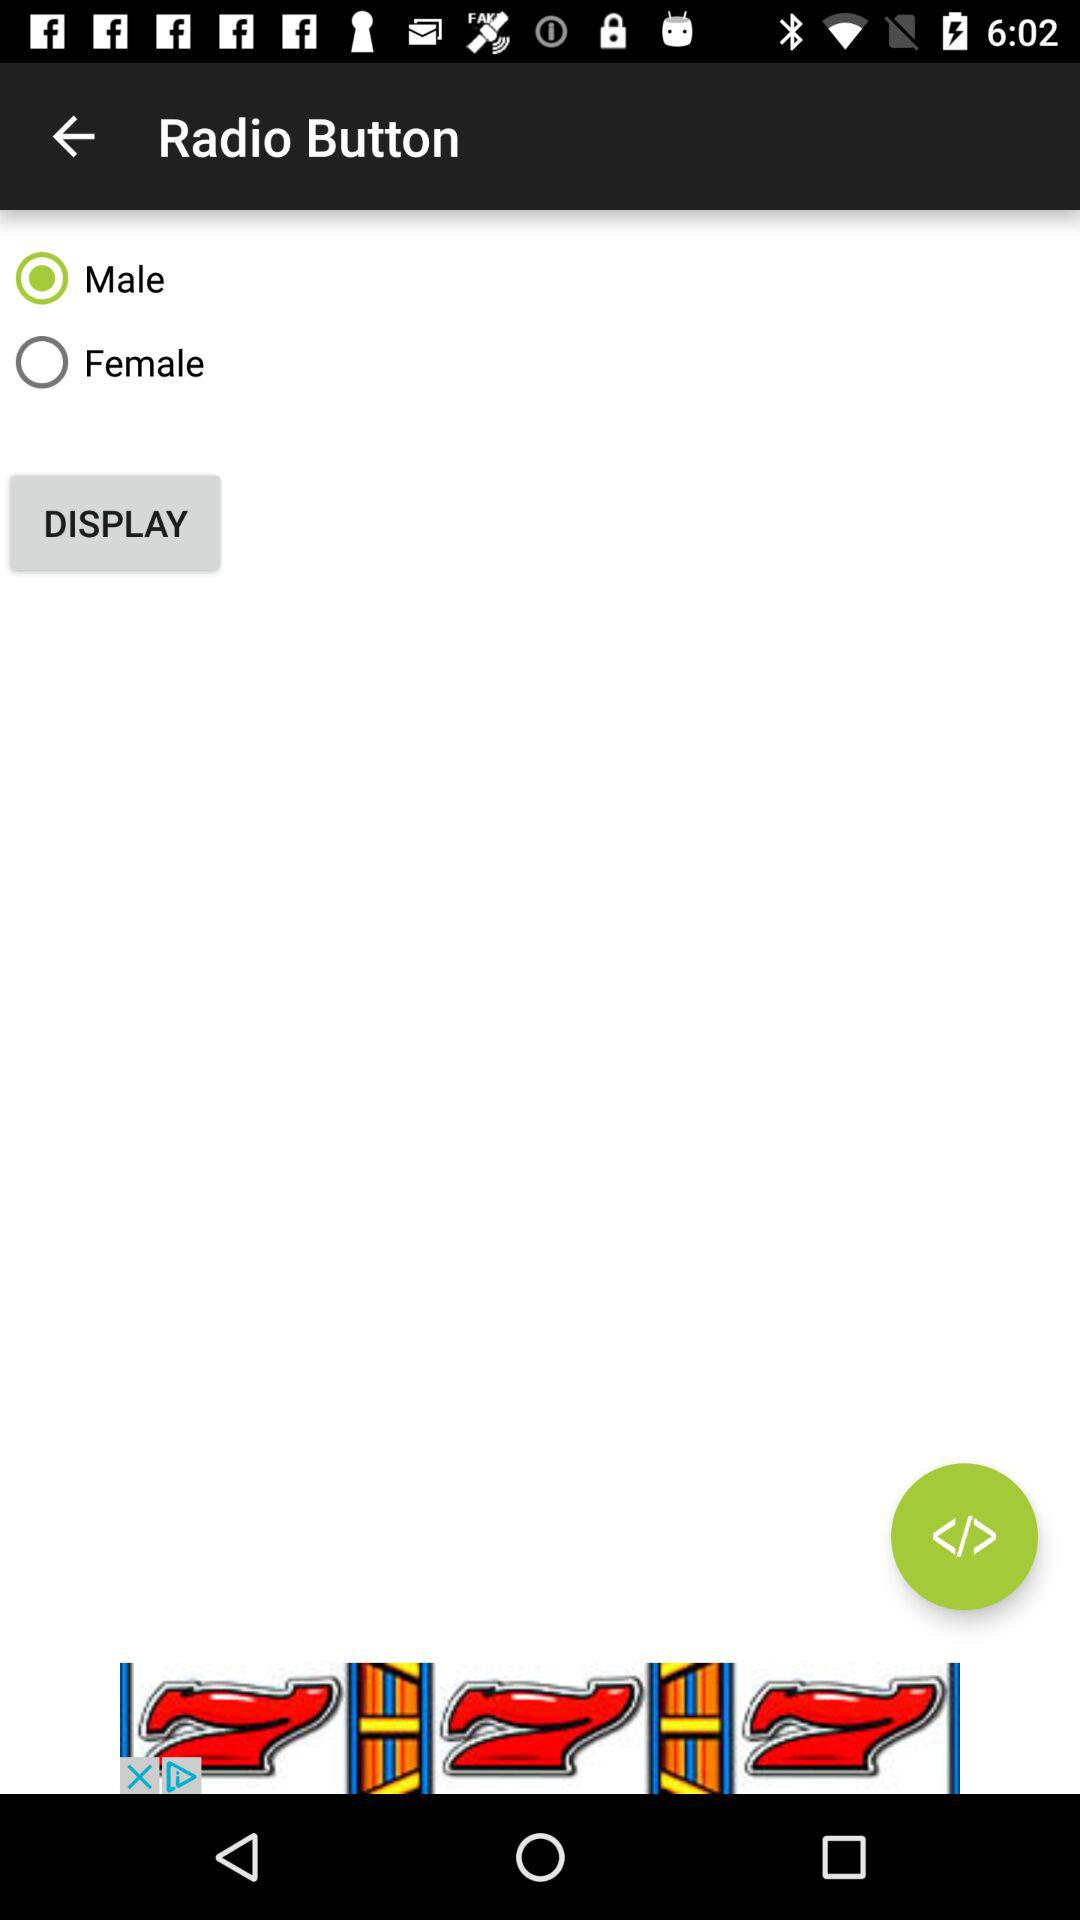What is the selected gender? The selected gender is male. 